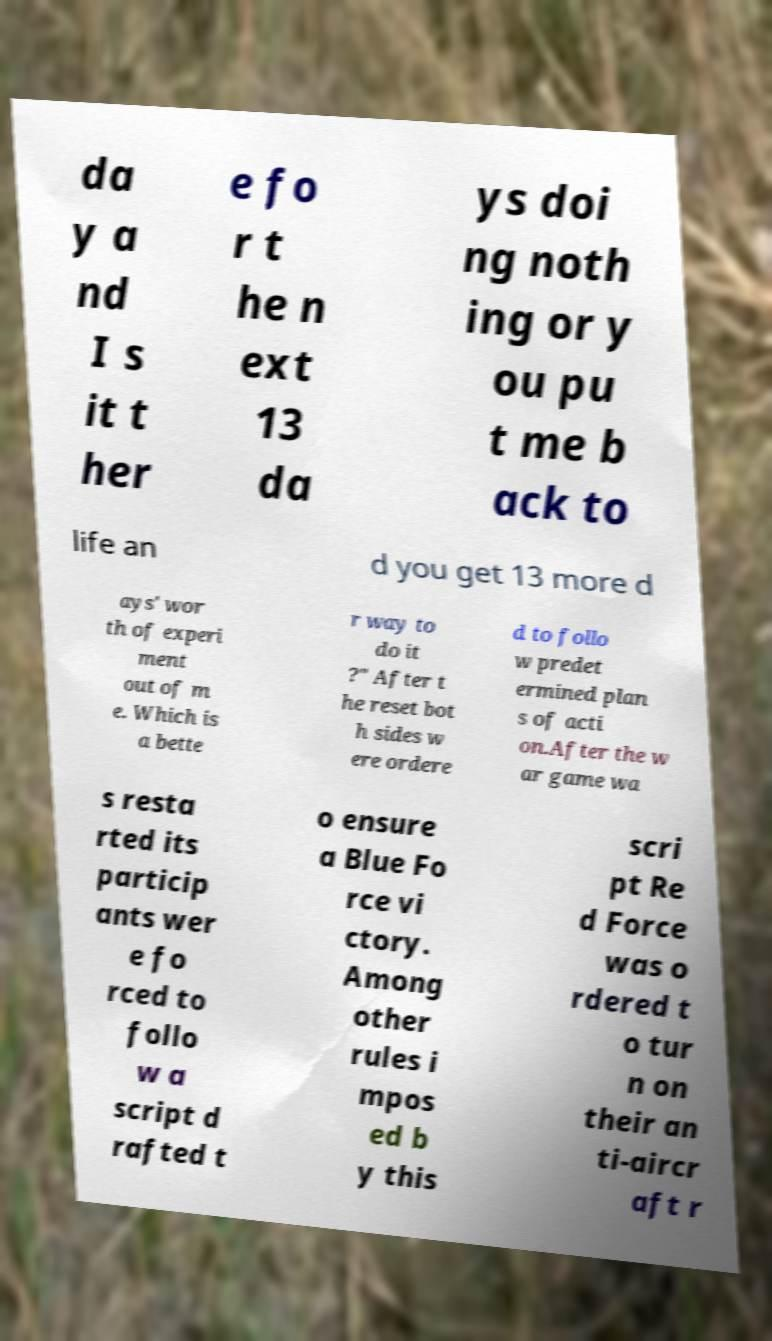Could you extract and type out the text from this image? da y a nd I s it t her e fo r t he n ext 13 da ys doi ng noth ing or y ou pu t me b ack to life an d you get 13 more d ays' wor th of experi ment out of m e. Which is a bette r way to do it ?" After t he reset bot h sides w ere ordere d to follo w predet ermined plan s of acti on.After the w ar game wa s resta rted its particip ants wer e fo rced to follo w a script d rafted t o ensure a Blue Fo rce vi ctory. Among other rules i mpos ed b y this scri pt Re d Force was o rdered t o tur n on their an ti-aircr aft r 